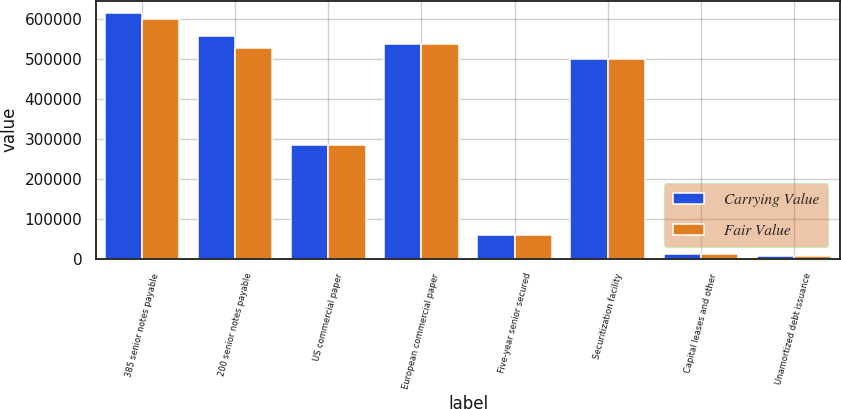<chart> <loc_0><loc_0><loc_500><loc_500><stacked_bar_chart><ecel><fcel>385 senior notes payable<fcel>200 senior notes payable<fcel>US commercial paper<fcel>European commercial paper<fcel>Five-year senior secured<fcel>Securitization facility<fcel>Capital leases and other<fcel>Unamortized debt issuance<nl><fcel>Carrying Value<fcel>615006<fcel>556460<fcel>283800<fcel>536503<fcel>60672<fcel>500000<fcel>11643<fcel>7117<nl><fcel>Fair Value<fcel>600000<fcel>525984<fcel>283800<fcel>536503<fcel>60672<fcel>500000<fcel>11643<fcel>7117<nl></chart> 